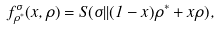<formula> <loc_0><loc_0><loc_500><loc_500>f _ { \rho ^ { * } } ^ { \sigma } ( x , \rho ) = S ( \sigma | | ( 1 - x ) \rho ^ { * } + x \rho ) ,</formula> 